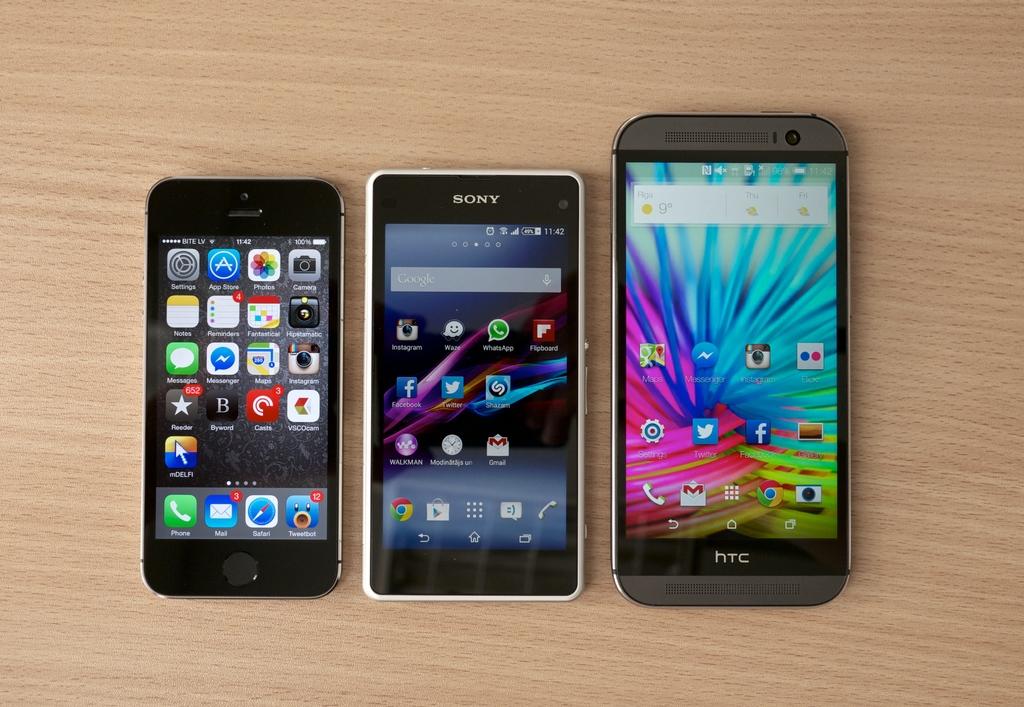What brand is the phone in the middle?
Provide a short and direct response. Sony. What brand is the phone on the right?
Your answer should be very brief. Htc. 